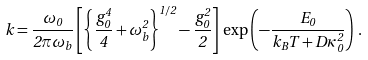Convert formula to latex. <formula><loc_0><loc_0><loc_500><loc_500>k = \frac { \omega _ { 0 } } { 2 \pi \omega _ { b } } \left [ \left \{ \frac { g _ { 0 } ^ { 4 } } { 4 } + \omega _ { b } ^ { 2 } \right \} ^ { 1 / 2 } - \frac { g _ { 0 } ^ { 2 } } { 2 } \right ] \, \exp \left ( - \frac { E _ { 0 } } { k _ { B } T + D \kappa _ { 0 } ^ { 2 } } \right ) \, .</formula> 